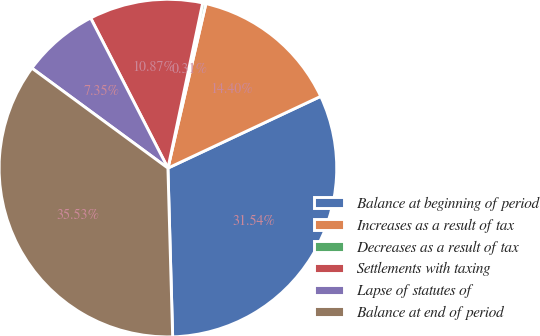Convert chart. <chart><loc_0><loc_0><loc_500><loc_500><pie_chart><fcel>Balance at beginning of period<fcel>Increases as a result of tax<fcel>Decreases as a result of tax<fcel>Settlements with taxing<fcel>Lapse of statutes of<fcel>Balance at end of period<nl><fcel>31.54%<fcel>14.4%<fcel>0.31%<fcel>10.87%<fcel>7.35%<fcel>35.53%<nl></chart> 